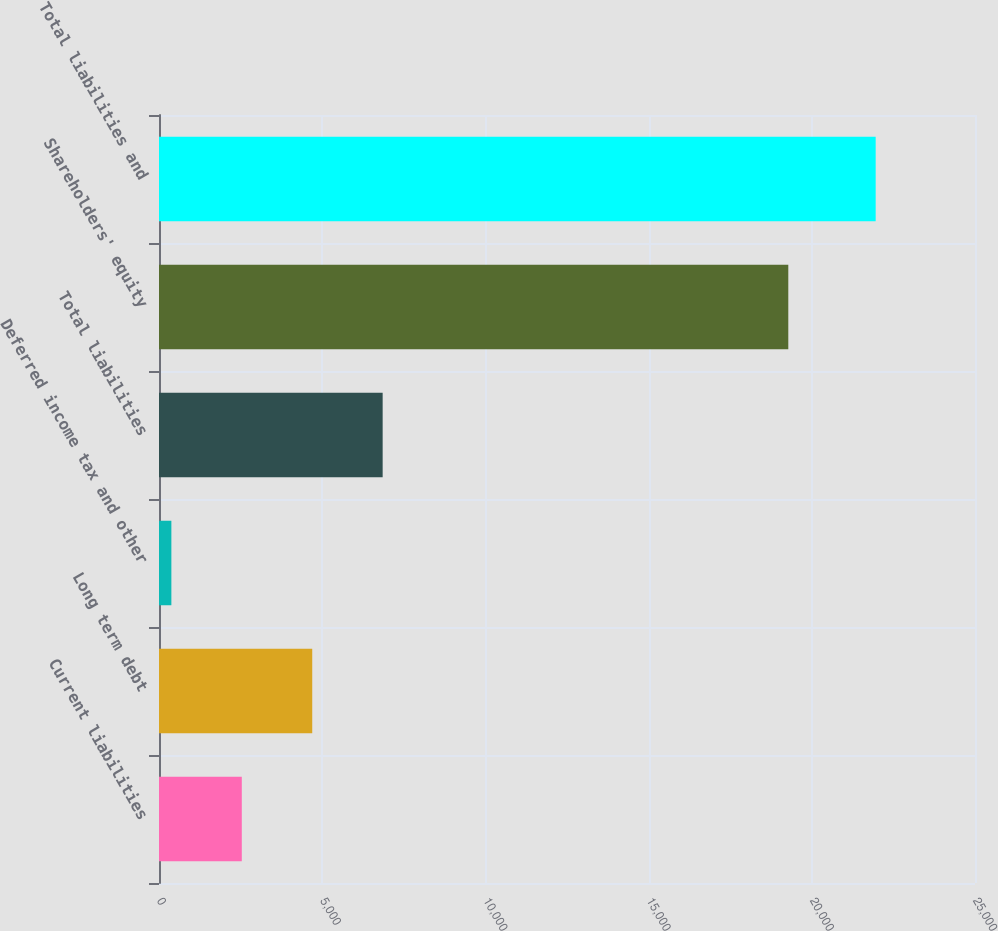Convert chart. <chart><loc_0><loc_0><loc_500><loc_500><bar_chart><fcel>Current liabilities<fcel>Long term debt<fcel>Deferred income tax and other<fcel>Total liabilities<fcel>Shareholders' equity<fcel>Total liabilities and<nl><fcel>2536.8<fcel>4694.6<fcel>379<fcel>6852.4<fcel>19280<fcel>21957<nl></chart> 